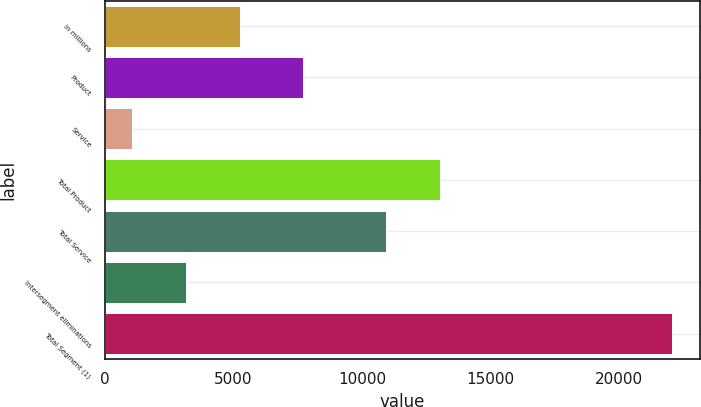Convert chart to OTSL. <chart><loc_0><loc_0><loc_500><loc_500><bar_chart><fcel>in millions<fcel>Product<fcel>Service<fcel>Total Product<fcel>Total Service<fcel>Intersegment eliminations<fcel>Total Segment (1)<nl><fcel>5252.4<fcel>7704<fcel>1055<fcel>13022.7<fcel>10924<fcel>3153.7<fcel>22042<nl></chart> 